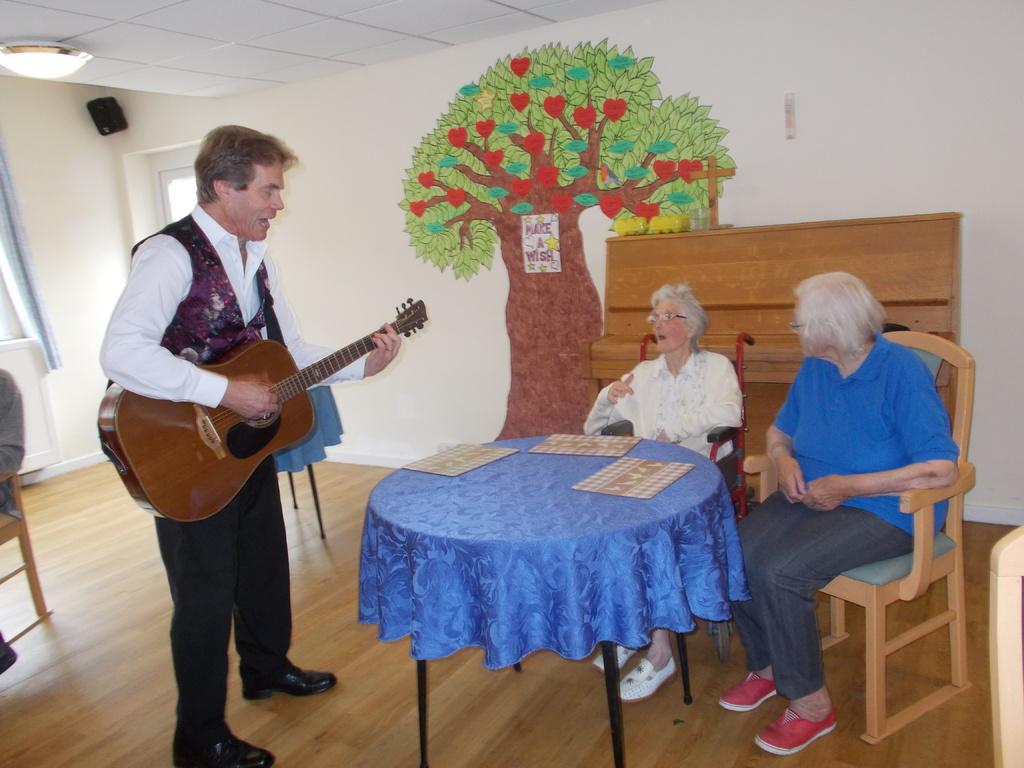How many people are sitting in the chair in the image? There are two people sitting in a chair in the image. What is located in front of the people sitting in the chair? The people are in front of a table. What is the man standing behind the people doing? The man is holding a guitar. Can you describe the piece of art on the wall in the image? The piece of art on the wall depicts a tree. How many times does the man sneeze while holding the guitar in the image? There is no indication in the image that the man is sneezing, and therefore no such activity can be observed. What part of the tree is visible in the piece of art on the wall? The piece of art on the wall depicts a tree, but it does not show a specific part of the tree. 